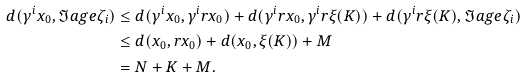<formula> <loc_0><loc_0><loc_500><loc_500>d ( \gamma ^ { i } x _ { 0 } , \Im a g e \zeta _ { i } ) & \leq d ( \gamma ^ { i } x _ { 0 } , \gamma ^ { i } r x _ { 0 } ) + d ( \gamma ^ { i } r x _ { 0 } , \gamma ^ { i } r \xi ( K ) ) + d ( \gamma ^ { i } r \xi ( K ) , \Im a g e \zeta _ { i } ) \\ & \leq d ( x _ { 0 } , r x _ { 0 } ) + d ( x _ { 0 } , \xi ( K ) ) + M \\ & = N + K + M .</formula> 